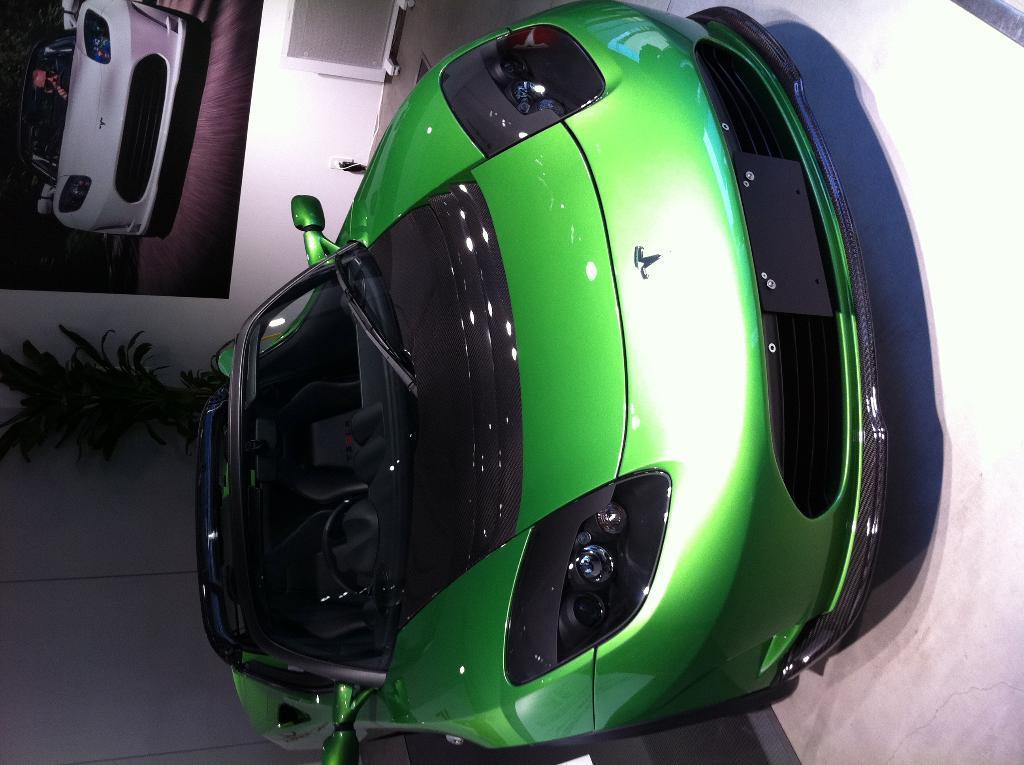Can you describe this image briefly? In this image, we can see a green car, we can see a wall, there is a photo of car on the wall. We can see a green plant. 